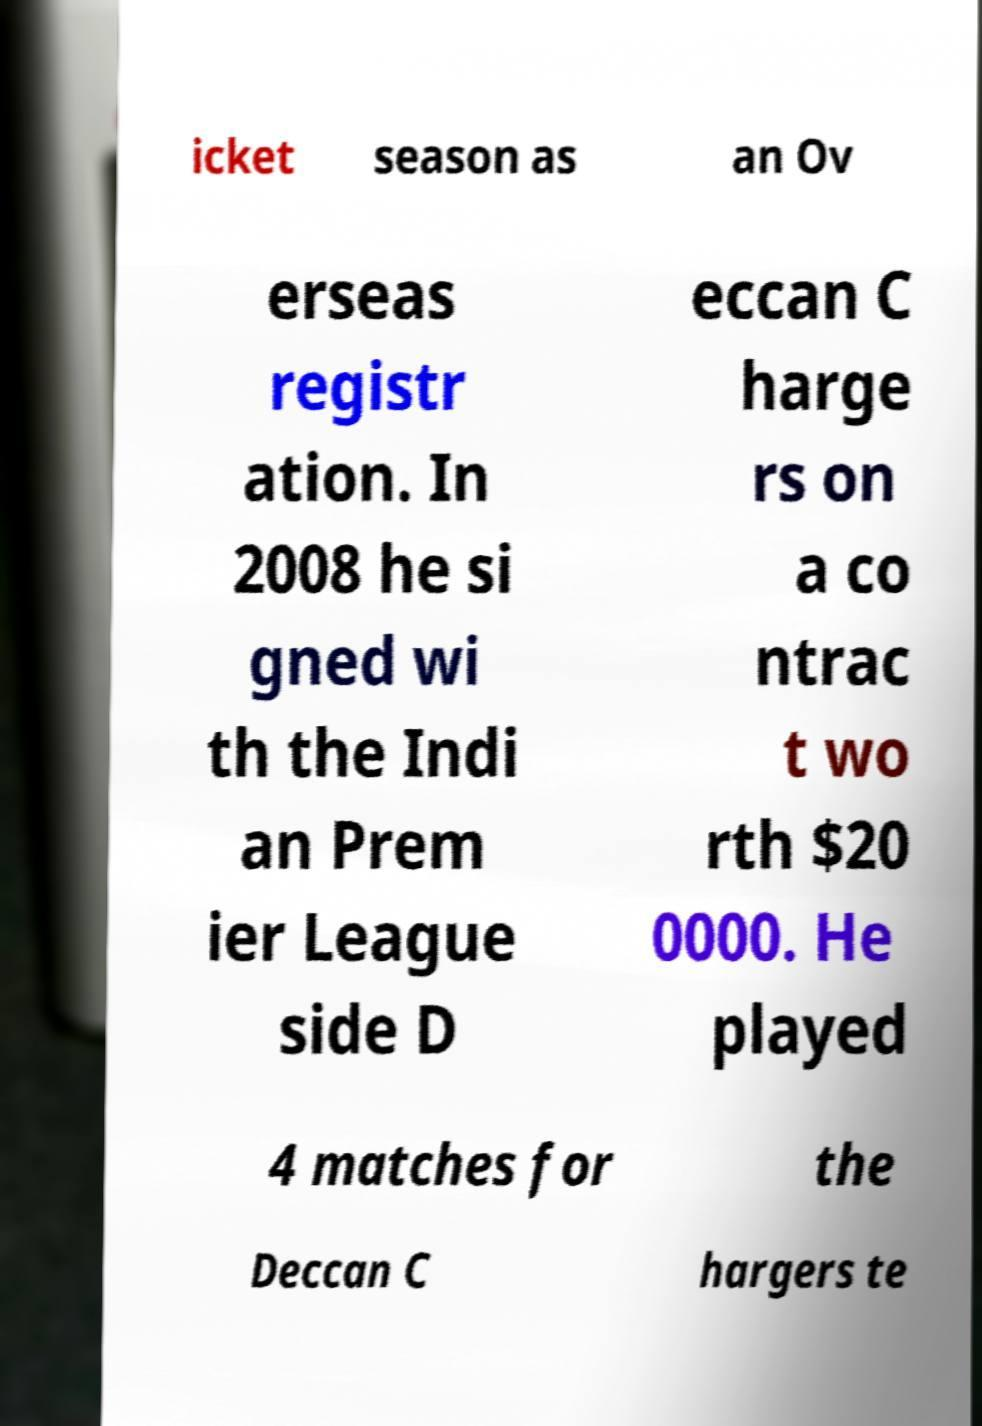Could you extract and type out the text from this image? icket season as an Ov erseas registr ation. In 2008 he si gned wi th the Indi an Prem ier League side D eccan C harge rs on a co ntrac t wo rth $20 0000. He played 4 matches for the Deccan C hargers te 